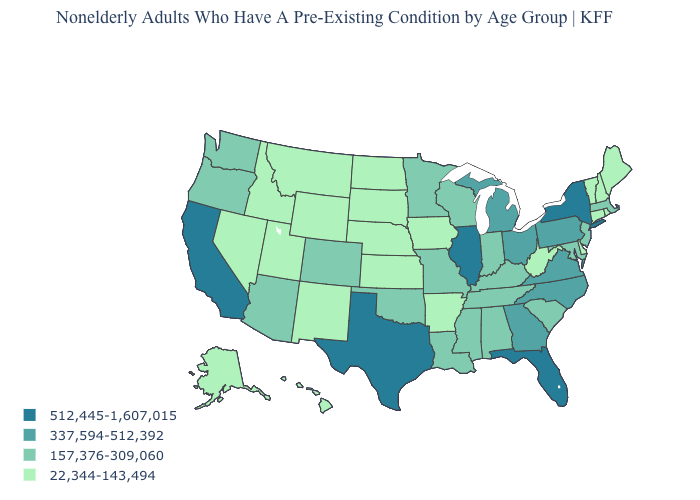Does the map have missing data?
Short answer required. No. What is the value of Delaware?
Concise answer only. 22,344-143,494. What is the value of Louisiana?
Short answer required. 157,376-309,060. Does Minnesota have the same value as Maryland?
Short answer required. Yes. Does Massachusetts have a lower value than Iowa?
Short answer required. No. Name the states that have a value in the range 157,376-309,060?
Keep it brief. Alabama, Arizona, Colorado, Indiana, Kentucky, Louisiana, Maryland, Massachusetts, Minnesota, Mississippi, Missouri, New Jersey, Oklahoma, Oregon, South Carolina, Tennessee, Washington, Wisconsin. What is the value of Arizona?
Short answer required. 157,376-309,060. Name the states that have a value in the range 337,594-512,392?
Concise answer only. Georgia, Michigan, North Carolina, Ohio, Pennsylvania, Virginia. Does the map have missing data?
Give a very brief answer. No. Name the states that have a value in the range 512,445-1,607,015?
Write a very short answer. California, Florida, Illinois, New York, Texas. What is the highest value in states that border Utah?
Give a very brief answer. 157,376-309,060. Does the map have missing data?
Short answer required. No. What is the value of Nevada?
Give a very brief answer. 22,344-143,494. What is the value of Ohio?
Concise answer only. 337,594-512,392. What is the value of Alabama?
Give a very brief answer. 157,376-309,060. 